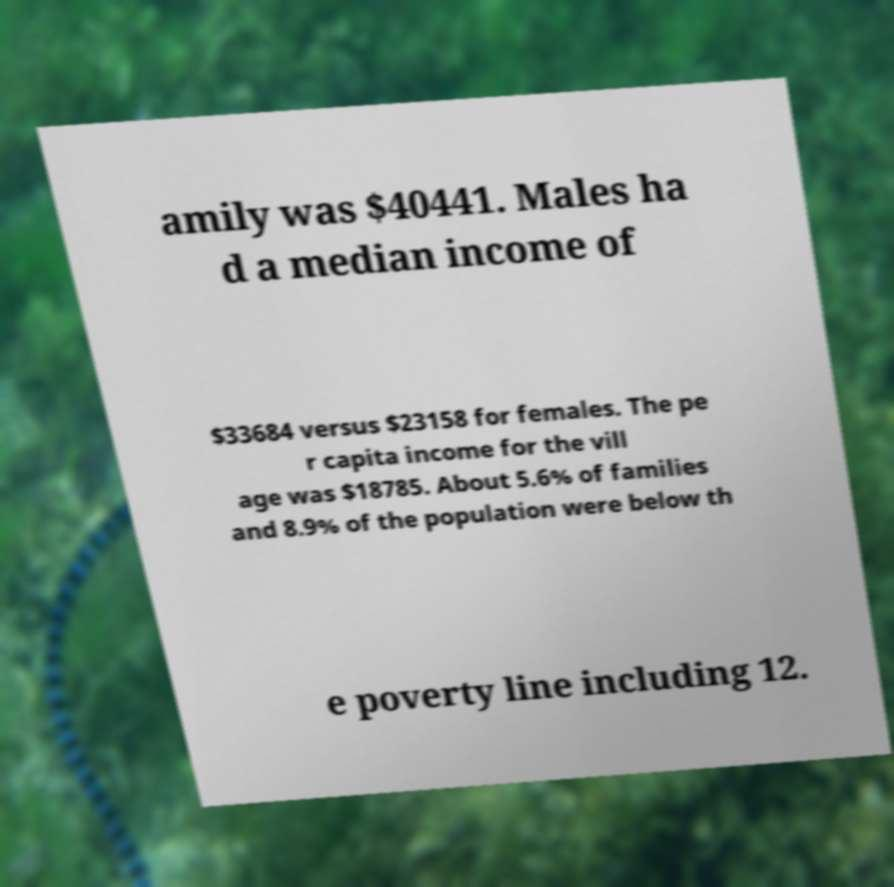I need the written content from this picture converted into text. Can you do that? amily was $40441. Males ha d a median income of $33684 versus $23158 for females. The pe r capita income for the vill age was $18785. About 5.6% of families and 8.9% of the population were below th e poverty line including 12. 